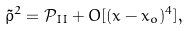Convert formula to latex. <formula><loc_0><loc_0><loc_500><loc_500>\tilde { \rho } ^ { 2 } = \mathcal { P } _ { I I } + O [ ( x - x _ { o } ) ^ { 4 } ] ,</formula> 